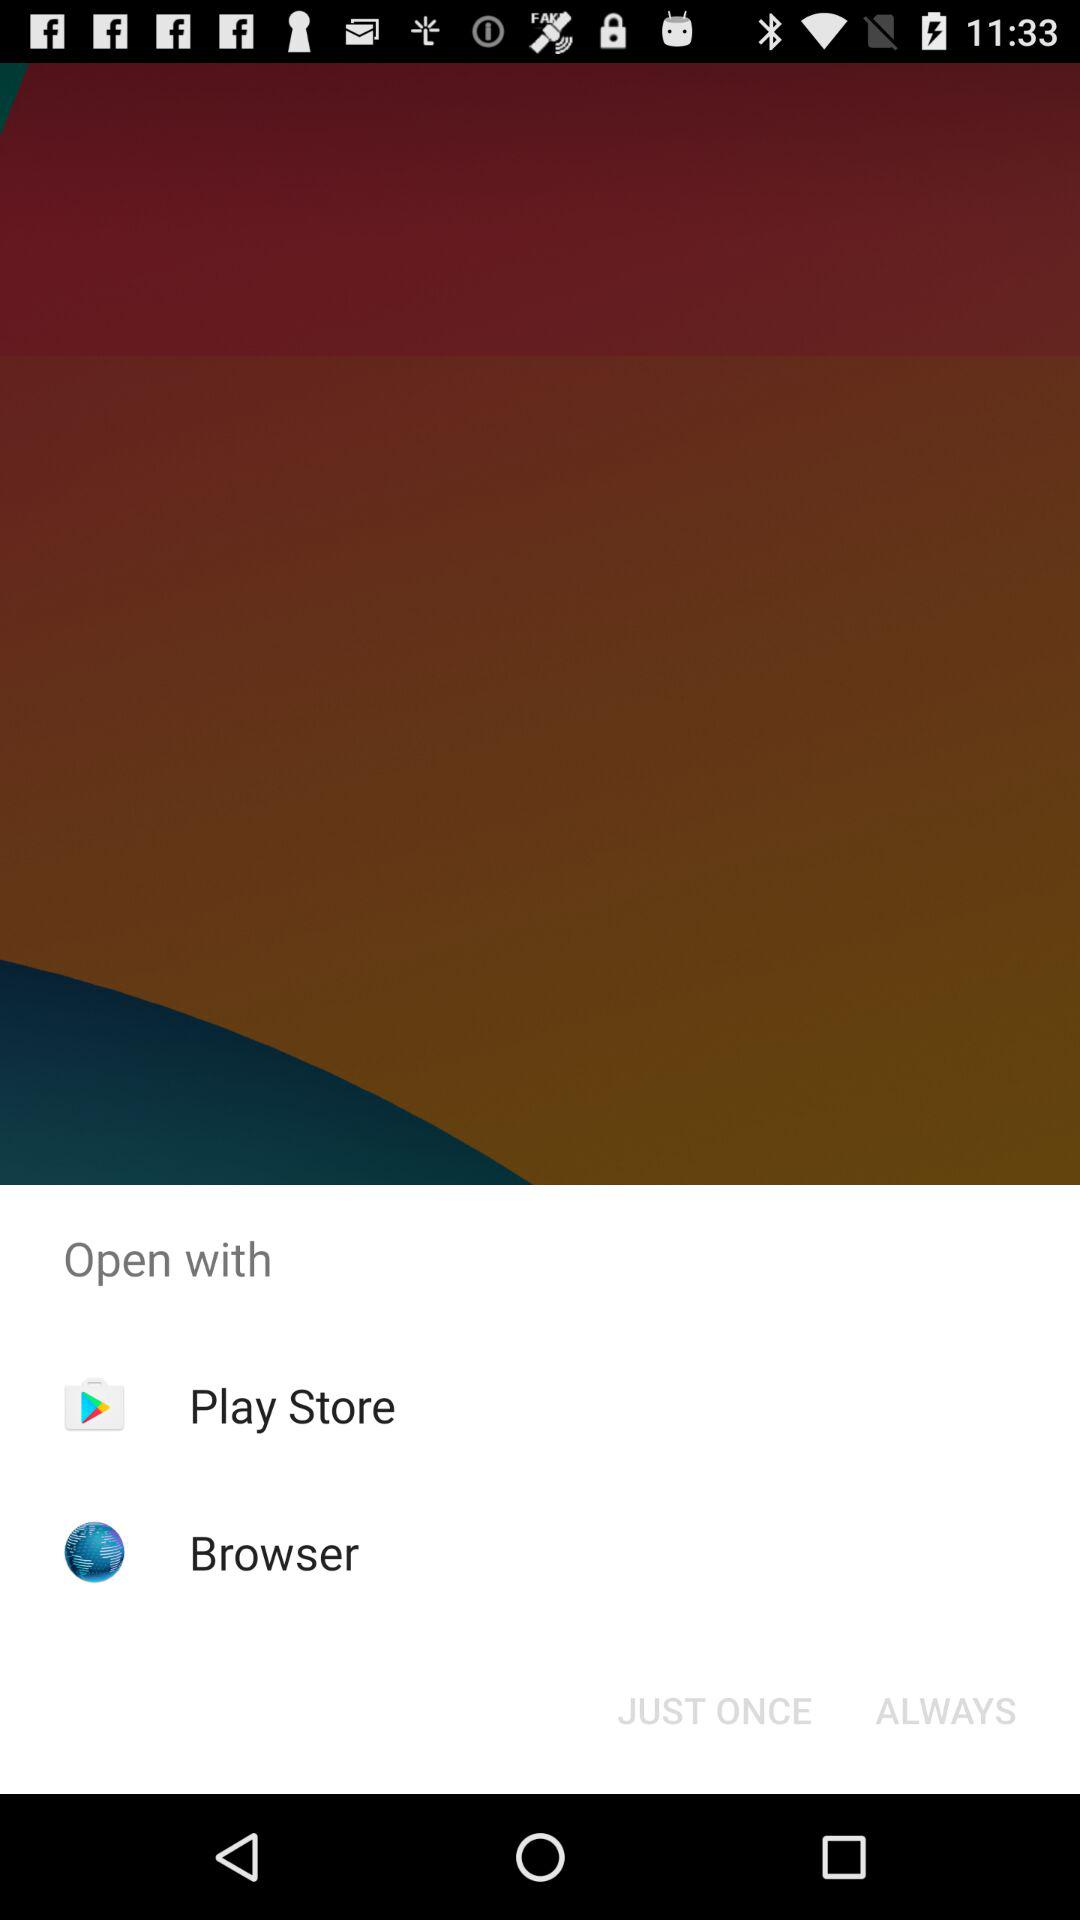What is the name of the application?
When the provided information is insufficient, respond with <no answer>. <no answer> 